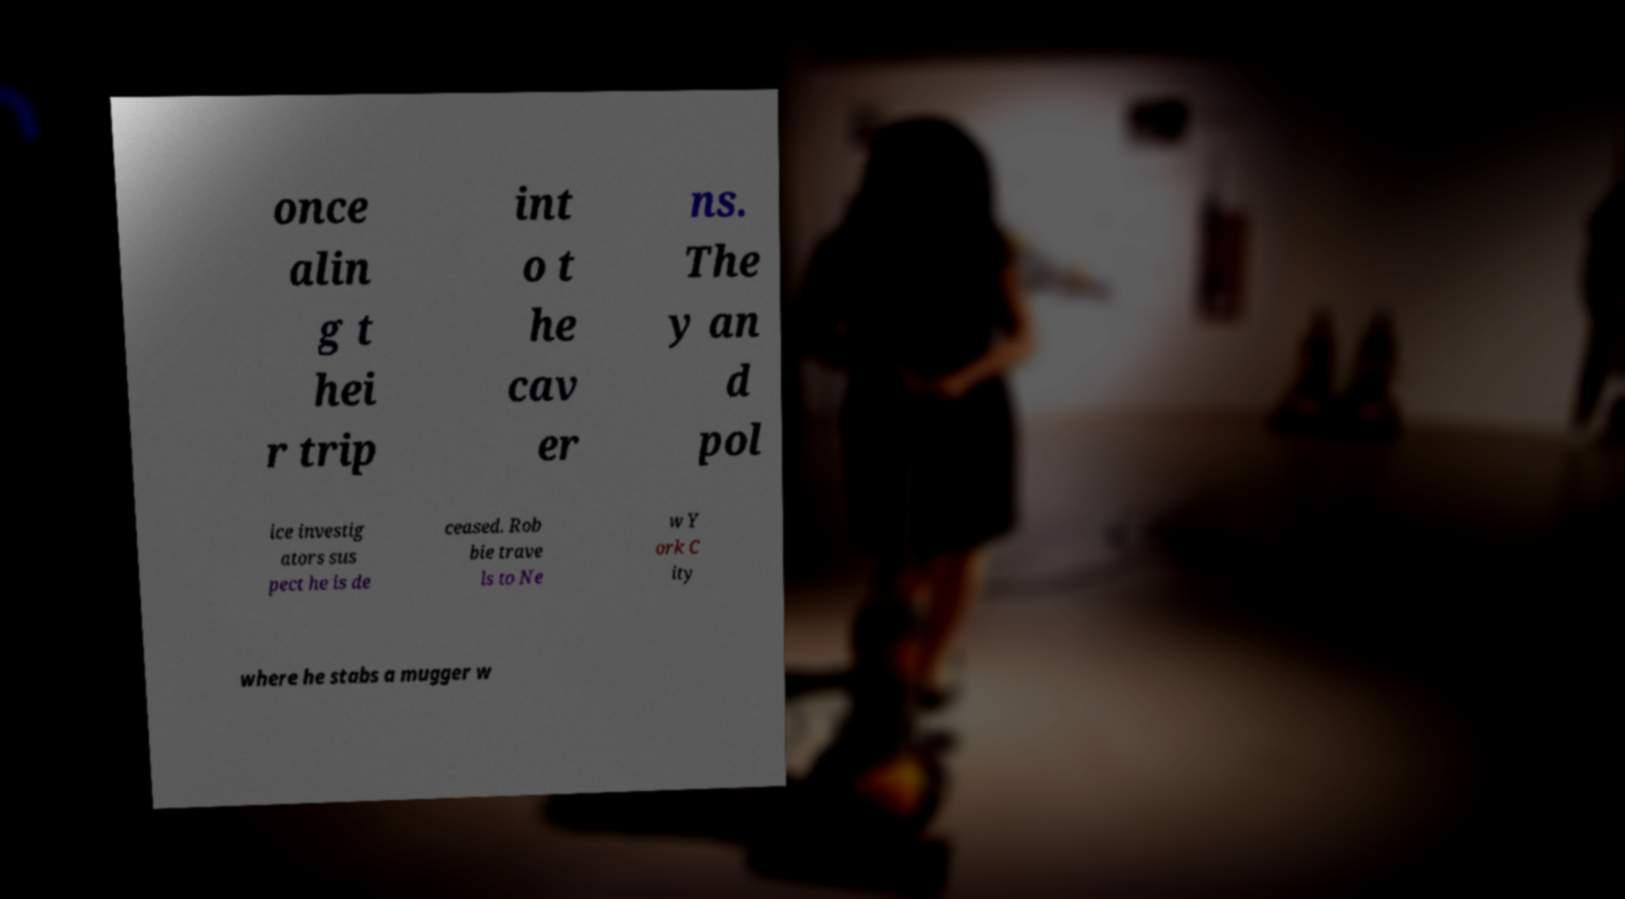I need the written content from this picture converted into text. Can you do that? once alin g t hei r trip int o t he cav er ns. The y an d pol ice investig ators sus pect he is de ceased. Rob bie trave ls to Ne w Y ork C ity where he stabs a mugger w 